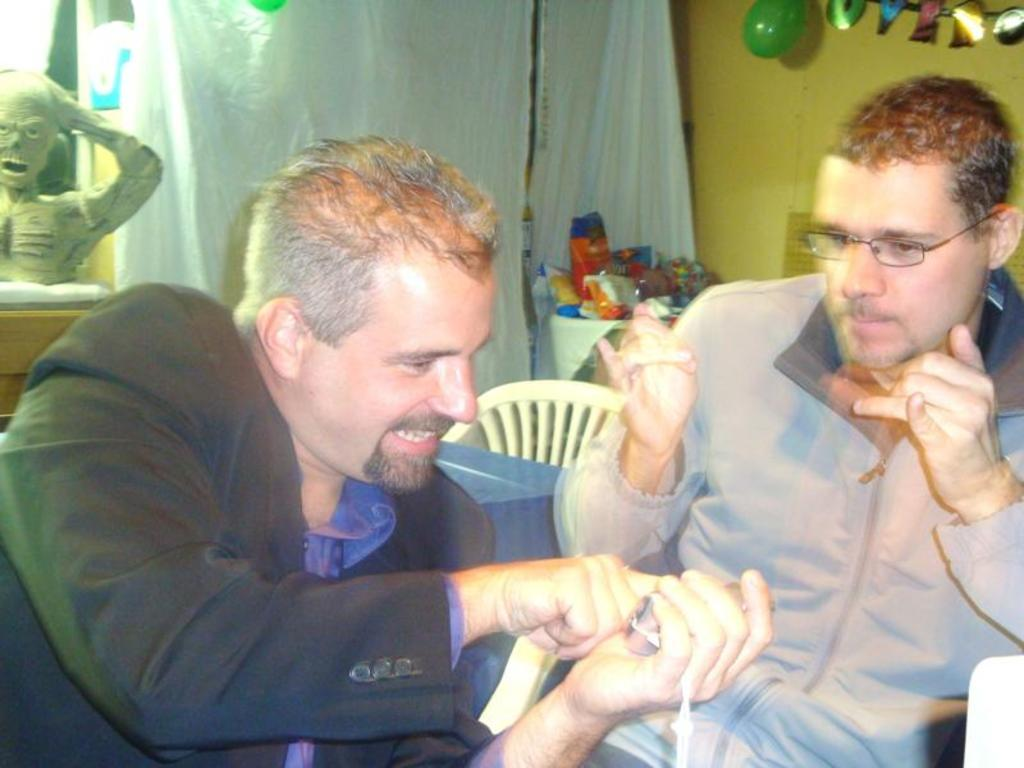How many men are sitting in the image? There are two men sitting on chairs in the image. What is the position of the chair in the background? There is a chair in the background of the image. What can be seen in the background of the image besides the chair? There is a balloon, a wall, a sculpture, and other objects in the background of the image. Can you tell me how many geese are flying over the church in the image? There is no church or geese present in the image. What type of lift is being used by the men in the image? The men are sitting on chairs, not using any type of lift. 